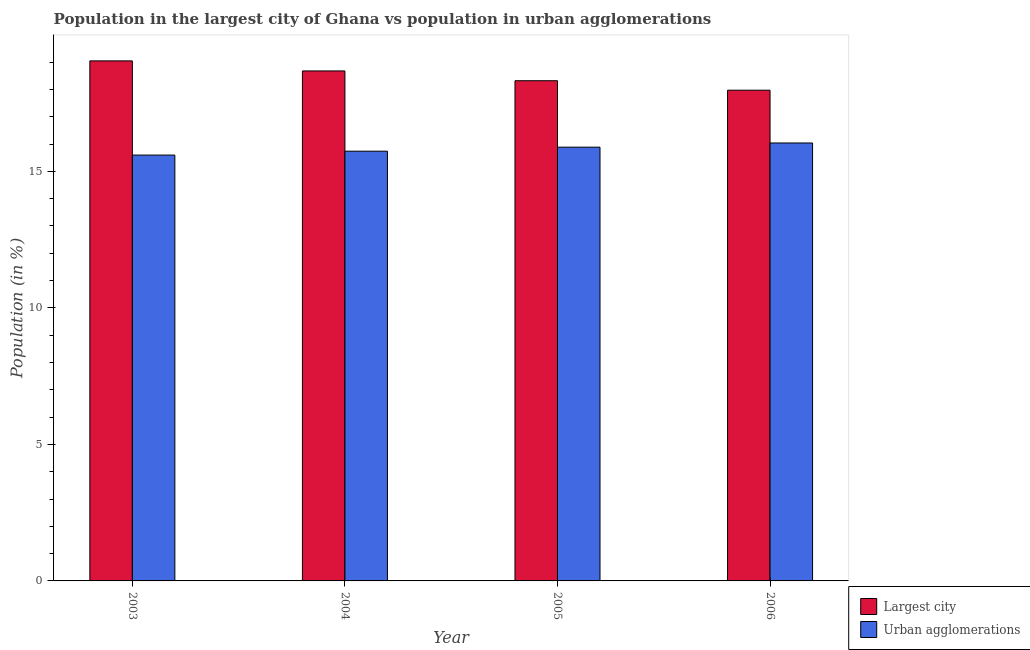How many groups of bars are there?
Provide a succinct answer. 4. How many bars are there on the 3rd tick from the left?
Provide a succinct answer. 2. What is the label of the 4th group of bars from the left?
Your answer should be very brief. 2006. In how many cases, is the number of bars for a given year not equal to the number of legend labels?
Keep it short and to the point. 0. What is the population in the largest city in 2005?
Provide a succinct answer. 18.32. Across all years, what is the maximum population in the largest city?
Offer a terse response. 19.05. Across all years, what is the minimum population in the largest city?
Your answer should be compact. 17.97. In which year was the population in urban agglomerations maximum?
Make the answer very short. 2006. What is the total population in urban agglomerations in the graph?
Provide a succinct answer. 63.26. What is the difference between the population in the largest city in 2004 and that in 2006?
Your answer should be compact. 0.71. What is the difference between the population in urban agglomerations in 2003 and the population in the largest city in 2006?
Offer a terse response. -0.44. What is the average population in the largest city per year?
Offer a terse response. 18.5. In how many years, is the population in urban agglomerations greater than 14 %?
Offer a terse response. 4. What is the ratio of the population in the largest city in 2003 to that in 2005?
Your response must be concise. 1.04. Is the population in the largest city in 2004 less than that in 2005?
Offer a very short reply. No. Is the difference between the population in the largest city in 2003 and 2006 greater than the difference between the population in urban agglomerations in 2003 and 2006?
Offer a very short reply. No. What is the difference between the highest and the second highest population in urban agglomerations?
Offer a terse response. 0.15. What is the difference between the highest and the lowest population in urban agglomerations?
Provide a short and direct response. 0.44. What does the 2nd bar from the left in 2006 represents?
Your answer should be very brief. Urban agglomerations. What does the 1st bar from the right in 2003 represents?
Your answer should be compact. Urban agglomerations. Are all the bars in the graph horizontal?
Offer a very short reply. No. What is the difference between two consecutive major ticks on the Y-axis?
Provide a succinct answer. 5. Does the graph contain any zero values?
Your answer should be compact. No. Does the graph contain grids?
Offer a terse response. No. Where does the legend appear in the graph?
Provide a succinct answer. Bottom right. How many legend labels are there?
Provide a succinct answer. 2. How are the legend labels stacked?
Offer a terse response. Vertical. What is the title of the graph?
Your answer should be compact. Population in the largest city of Ghana vs population in urban agglomerations. What is the Population (in %) of Largest city in 2003?
Your answer should be compact. 19.05. What is the Population (in %) in Urban agglomerations in 2003?
Your answer should be compact. 15.6. What is the Population (in %) in Largest city in 2004?
Your answer should be very brief. 18.68. What is the Population (in %) in Urban agglomerations in 2004?
Offer a terse response. 15.74. What is the Population (in %) in Largest city in 2005?
Provide a short and direct response. 18.32. What is the Population (in %) of Urban agglomerations in 2005?
Your answer should be very brief. 15.89. What is the Population (in %) in Largest city in 2006?
Offer a very short reply. 17.97. What is the Population (in %) of Urban agglomerations in 2006?
Keep it short and to the point. 16.04. Across all years, what is the maximum Population (in %) of Largest city?
Your answer should be very brief. 19.05. Across all years, what is the maximum Population (in %) in Urban agglomerations?
Offer a terse response. 16.04. Across all years, what is the minimum Population (in %) of Largest city?
Provide a short and direct response. 17.97. Across all years, what is the minimum Population (in %) in Urban agglomerations?
Your response must be concise. 15.6. What is the total Population (in %) of Largest city in the graph?
Your answer should be very brief. 74.02. What is the total Population (in %) in Urban agglomerations in the graph?
Keep it short and to the point. 63.26. What is the difference between the Population (in %) in Largest city in 2003 and that in 2004?
Ensure brevity in your answer.  0.37. What is the difference between the Population (in %) in Urban agglomerations in 2003 and that in 2004?
Your answer should be compact. -0.14. What is the difference between the Population (in %) of Largest city in 2003 and that in 2005?
Offer a terse response. 0.73. What is the difference between the Population (in %) in Urban agglomerations in 2003 and that in 2005?
Offer a terse response. -0.29. What is the difference between the Population (in %) in Largest city in 2003 and that in 2006?
Provide a short and direct response. 1.07. What is the difference between the Population (in %) of Urban agglomerations in 2003 and that in 2006?
Ensure brevity in your answer.  -0.44. What is the difference between the Population (in %) of Largest city in 2004 and that in 2005?
Offer a very short reply. 0.36. What is the difference between the Population (in %) in Urban agglomerations in 2004 and that in 2005?
Provide a short and direct response. -0.15. What is the difference between the Population (in %) in Largest city in 2004 and that in 2006?
Offer a very short reply. 0.71. What is the difference between the Population (in %) of Urban agglomerations in 2004 and that in 2006?
Your answer should be compact. -0.3. What is the difference between the Population (in %) of Largest city in 2005 and that in 2006?
Keep it short and to the point. 0.35. What is the difference between the Population (in %) of Urban agglomerations in 2005 and that in 2006?
Make the answer very short. -0.15. What is the difference between the Population (in %) of Largest city in 2003 and the Population (in %) of Urban agglomerations in 2004?
Your answer should be very brief. 3.31. What is the difference between the Population (in %) of Largest city in 2003 and the Population (in %) of Urban agglomerations in 2005?
Provide a short and direct response. 3.16. What is the difference between the Population (in %) of Largest city in 2003 and the Population (in %) of Urban agglomerations in 2006?
Offer a very short reply. 3.01. What is the difference between the Population (in %) of Largest city in 2004 and the Population (in %) of Urban agglomerations in 2005?
Your response must be concise. 2.79. What is the difference between the Population (in %) of Largest city in 2004 and the Population (in %) of Urban agglomerations in 2006?
Your answer should be compact. 2.64. What is the difference between the Population (in %) of Largest city in 2005 and the Population (in %) of Urban agglomerations in 2006?
Offer a very short reply. 2.28. What is the average Population (in %) in Largest city per year?
Provide a short and direct response. 18.5. What is the average Population (in %) of Urban agglomerations per year?
Your answer should be compact. 15.82. In the year 2003, what is the difference between the Population (in %) in Largest city and Population (in %) in Urban agglomerations?
Provide a succinct answer. 3.45. In the year 2004, what is the difference between the Population (in %) of Largest city and Population (in %) of Urban agglomerations?
Make the answer very short. 2.94. In the year 2005, what is the difference between the Population (in %) of Largest city and Population (in %) of Urban agglomerations?
Make the answer very short. 2.43. In the year 2006, what is the difference between the Population (in %) of Largest city and Population (in %) of Urban agglomerations?
Your answer should be very brief. 1.93. What is the ratio of the Population (in %) in Largest city in 2003 to that in 2004?
Your answer should be very brief. 1.02. What is the ratio of the Population (in %) of Urban agglomerations in 2003 to that in 2004?
Your response must be concise. 0.99. What is the ratio of the Population (in %) of Largest city in 2003 to that in 2005?
Your response must be concise. 1.04. What is the ratio of the Population (in %) in Urban agglomerations in 2003 to that in 2005?
Your answer should be compact. 0.98. What is the ratio of the Population (in %) in Largest city in 2003 to that in 2006?
Your response must be concise. 1.06. What is the ratio of the Population (in %) in Urban agglomerations in 2003 to that in 2006?
Make the answer very short. 0.97. What is the ratio of the Population (in %) in Largest city in 2004 to that in 2005?
Ensure brevity in your answer.  1.02. What is the ratio of the Population (in %) of Urban agglomerations in 2004 to that in 2005?
Your response must be concise. 0.99. What is the ratio of the Population (in %) in Largest city in 2004 to that in 2006?
Offer a very short reply. 1.04. What is the ratio of the Population (in %) in Urban agglomerations in 2004 to that in 2006?
Your answer should be compact. 0.98. What is the ratio of the Population (in %) in Largest city in 2005 to that in 2006?
Provide a succinct answer. 1.02. What is the ratio of the Population (in %) in Urban agglomerations in 2005 to that in 2006?
Your response must be concise. 0.99. What is the difference between the highest and the second highest Population (in %) of Largest city?
Ensure brevity in your answer.  0.37. What is the difference between the highest and the second highest Population (in %) in Urban agglomerations?
Give a very brief answer. 0.15. What is the difference between the highest and the lowest Population (in %) of Largest city?
Offer a very short reply. 1.07. What is the difference between the highest and the lowest Population (in %) of Urban agglomerations?
Ensure brevity in your answer.  0.44. 